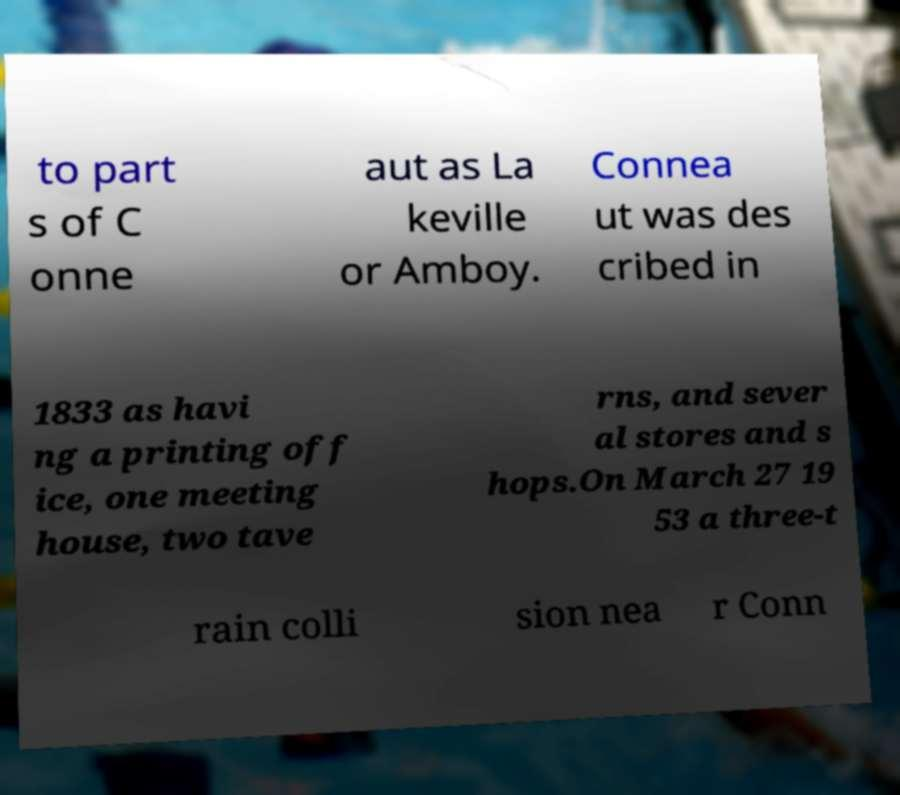I need the written content from this picture converted into text. Can you do that? to part s of C onne aut as La keville or Amboy. Connea ut was des cribed in 1833 as havi ng a printing off ice, one meeting house, two tave rns, and sever al stores and s hops.On March 27 19 53 a three-t rain colli sion nea r Conn 